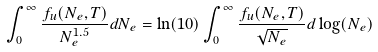Convert formula to latex. <formula><loc_0><loc_0><loc_500><loc_500>\int _ { 0 } ^ { \infty } \frac { f _ { u } ( N _ { e } , T ) } { N _ { e } ^ { 1 . 5 } } d N _ { e } = \ln ( 1 0 ) \int _ { 0 } ^ { \infty } \frac { f _ { u } ( N _ { e } , T ) } { \sqrt { N _ { e } } } d \log ( N _ { e } )</formula> 